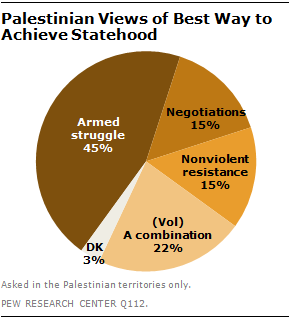Indicate a few pertinent items in this graphic. The largest segment has the darkest color. 